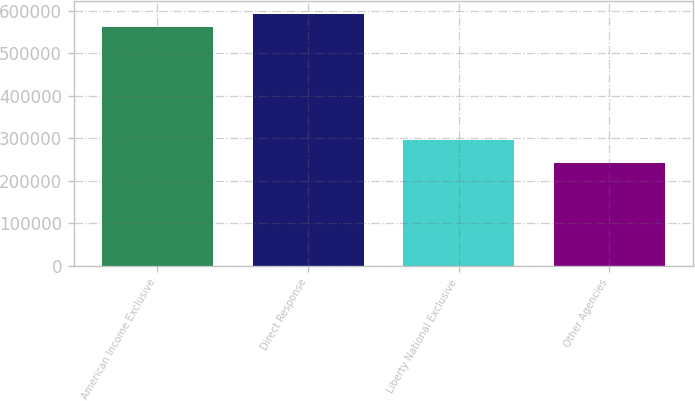Convert chart. <chart><loc_0><loc_0><loc_500><loc_500><bar_chart><fcel>American Income Exclusive<fcel>Direct Response<fcel>Liberty National Exclusive<fcel>Other Agencies<nl><fcel>560649<fcel>593124<fcel>294587<fcel>241859<nl></chart> 